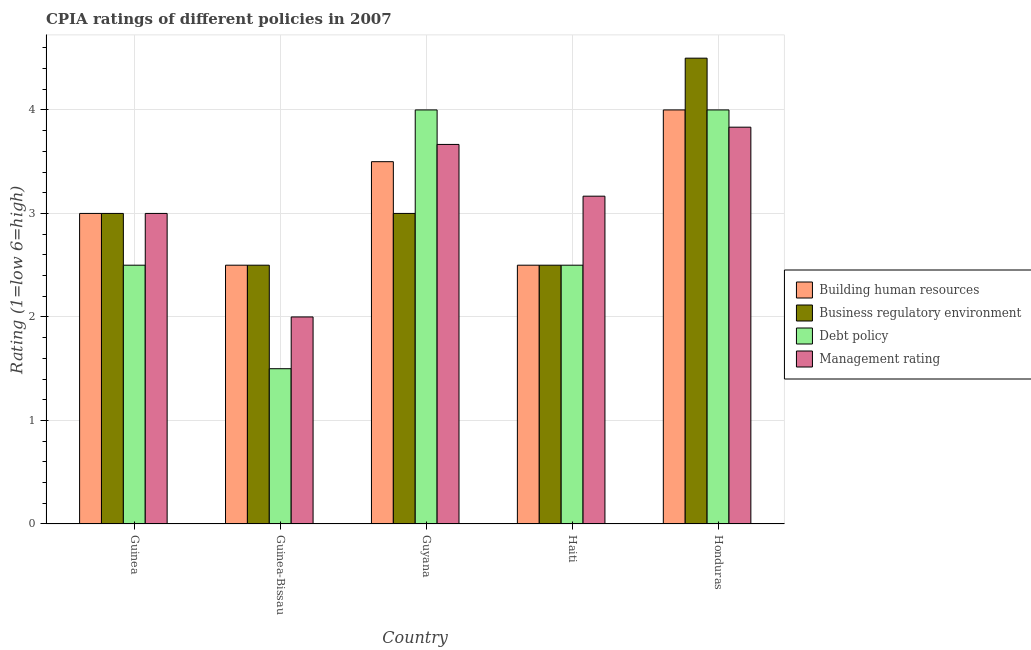How many groups of bars are there?
Make the answer very short. 5. Are the number of bars per tick equal to the number of legend labels?
Your answer should be compact. Yes. How many bars are there on the 1st tick from the left?
Give a very brief answer. 4. How many bars are there on the 3rd tick from the right?
Your response must be concise. 4. What is the label of the 4th group of bars from the left?
Make the answer very short. Haiti. In how many cases, is the number of bars for a given country not equal to the number of legend labels?
Keep it short and to the point. 0. Across all countries, what is the maximum cpia rating of management?
Make the answer very short. 3.83. Across all countries, what is the minimum cpia rating of debt policy?
Your answer should be compact. 1.5. In which country was the cpia rating of business regulatory environment maximum?
Give a very brief answer. Honduras. In which country was the cpia rating of building human resources minimum?
Keep it short and to the point. Guinea-Bissau. What is the total cpia rating of debt policy in the graph?
Make the answer very short. 14.5. What is the difference between the cpia rating of building human resources in Guinea-Bissau and that in Honduras?
Provide a succinct answer. -1.5. What is the average cpia rating of building human resources per country?
Provide a short and direct response. 3.1. What is the difference between the cpia rating of debt policy and cpia rating of management in Honduras?
Provide a short and direct response. 0.17. In how many countries, is the cpia rating of building human resources greater than 0.6000000000000001 ?
Give a very brief answer. 5. What is the ratio of the cpia rating of building human resources in Guyana to that in Honduras?
Offer a terse response. 0.88. Is the difference between the cpia rating of building human resources in Guinea and Haiti greater than the difference between the cpia rating of business regulatory environment in Guinea and Haiti?
Offer a very short reply. No. In how many countries, is the cpia rating of management greater than the average cpia rating of management taken over all countries?
Give a very brief answer. 3. Is the sum of the cpia rating of building human resources in Guyana and Honduras greater than the maximum cpia rating of debt policy across all countries?
Your response must be concise. Yes. What does the 2nd bar from the left in Guyana represents?
Ensure brevity in your answer.  Business regulatory environment. What does the 1st bar from the right in Guinea-Bissau represents?
Provide a succinct answer. Management rating. How many bars are there?
Your answer should be very brief. 20. Are all the bars in the graph horizontal?
Your response must be concise. No. How many countries are there in the graph?
Offer a very short reply. 5. What is the difference between two consecutive major ticks on the Y-axis?
Ensure brevity in your answer.  1. Does the graph contain any zero values?
Your answer should be compact. No. What is the title of the graph?
Keep it short and to the point. CPIA ratings of different policies in 2007. Does "Offering training" appear as one of the legend labels in the graph?
Your answer should be compact. No. What is the Rating (1=low 6=high) in Building human resources in Guinea?
Your answer should be very brief. 3. What is the Rating (1=low 6=high) in Business regulatory environment in Guinea-Bissau?
Keep it short and to the point. 2.5. What is the Rating (1=low 6=high) in Building human resources in Guyana?
Ensure brevity in your answer.  3.5. What is the Rating (1=low 6=high) of Management rating in Guyana?
Ensure brevity in your answer.  3.67. What is the Rating (1=low 6=high) in Building human resources in Haiti?
Your answer should be very brief. 2.5. What is the Rating (1=low 6=high) in Business regulatory environment in Haiti?
Keep it short and to the point. 2.5. What is the Rating (1=low 6=high) of Management rating in Haiti?
Your response must be concise. 3.17. What is the Rating (1=low 6=high) in Building human resources in Honduras?
Your answer should be compact. 4. What is the Rating (1=low 6=high) in Management rating in Honduras?
Give a very brief answer. 3.83. Across all countries, what is the maximum Rating (1=low 6=high) of Building human resources?
Offer a terse response. 4. Across all countries, what is the maximum Rating (1=low 6=high) of Business regulatory environment?
Keep it short and to the point. 4.5. Across all countries, what is the maximum Rating (1=low 6=high) of Management rating?
Provide a succinct answer. 3.83. What is the total Rating (1=low 6=high) in Building human resources in the graph?
Your answer should be very brief. 15.5. What is the total Rating (1=low 6=high) in Debt policy in the graph?
Offer a terse response. 14.5. What is the total Rating (1=low 6=high) of Management rating in the graph?
Ensure brevity in your answer.  15.67. What is the difference between the Rating (1=low 6=high) of Business regulatory environment in Guinea and that in Guinea-Bissau?
Offer a terse response. 0.5. What is the difference between the Rating (1=low 6=high) in Management rating in Guinea and that in Guinea-Bissau?
Your answer should be compact. 1. What is the difference between the Rating (1=low 6=high) in Building human resources in Guinea and that in Guyana?
Make the answer very short. -0.5. What is the difference between the Rating (1=low 6=high) of Business regulatory environment in Guinea and that in Guyana?
Give a very brief answer. 0. What is the difference between the Rating (1=low 6=high) of Debt policy in Guinea and that in Guyana?
Make the answer very short. -1.5. What is the difference between the Rating (1=low 6=high) in Management rating in Guinea and that in Guyana?
Give a very brief answer. -0.67. What is the difference between the Rating (1=low 6=high) of Building human resources in Guinea and that in Haiti?
Your answer should be very brief. 0.5. What is the difference between the Rating (1=low 6=high) in Debt policy in Guinea and that in Haiti?
Make the answer very short. 0. What is the difference between the Rating (1=low 6=high) of Business regulatory environment in Guinea and that in Honduras?
Your answer should be very brief. -1.5. What is the difference between the Rating (1=low 6=high) of Management rating in Guinea and that in Honduras?
Ensure brevity in your answer.  -0.83. What is the difference between the Rating (1=low 6=high) of Debt policy in Guinea-Bissau and that in Guyana?
Give a very brief answer. -2.5. What is the difference between the Rating (1=low 6=high) of Management rating in Guinea-Bissau and that in Guyana?
Your answer should be compact. -1.67. What is the difference between the Rating (1=low 6=high) of Building human resources in Guinea-Bissau and that in Haiti?
Ensure brevity in your answer.  0. What is the difference between the Rating (1=low 6=high) in Management rating in Guinea-Bissau and that in Haiti?
Offer a terse response. -1.17. What is the difference between the Rating (1=low 6=high) in Management rating in Guinea-Bissau and that in Honduras?
Your response must be concise. -1.83. What is the difference between the Rating (1=low 6=high) of Building human resources in Guyana and that in Haiti?
Your answer should be compact. 1. What is the difference between the Rating (1=low 6=high) in Debt policy in Guyana and that in Haiti?
Provide a succinct answer. 1.5. What is the difference between the Rating (1=low 6=high) in Debt policy in Guyana and that in Honduras?
Give a very brief answer. 0. What is the difference between the Rating (1=low 6=high) in Building human resources in Haiti and that in Honduras?
Your answer should be very brief. -1.5. What is the difference between the Rating (1=low 6=high) of Business regulatory environment in Haiti and that in Honduras?
Give a very brief answer. -2. What is the difference between the Rating (1=low 6=high) in Debt policy in Haiti and that in Honduras?
Make the answer very short. -1.5. What is the difference between the Rating (1=low 6=high) in Building human resources in Guinea and the Rating (1=low 6=high) in Business regulatory environment in Guinea-Bissau?
Ensure brevity in your answer.  0.5. What is the difference between the Rating (1=low 6=high) in Building human resources in Guinea and the Rating (1=low 6=high) in Management rating in Guyana?
Make the answer very short. -0.67. What is the difference between the Rating (1=low 6=high) of Business regulatory environment in Guinea and the Rating (1=low 6=high) of Debt policy in Guyana?
Give a very brief answer. -1. What is the difference between the Rating (1=low 6=high) in Business regulatory environment in Guinea and the Rating (1=low 6=high) in Management rating in Guyana?
Keep it short and to the point. -0.67. What is the difference between the Rating (1=low 6=high) in Debt policy in Guinea and the Rating (1=low 6=high) in Management rating in Guyana?
Ensure brevity in your answer.  -1.17. What is the difference between the Rating (1=low 6=high) of Building human resources in Guinea and the Rating (1=low 6=high) of Business regulatory environment in Haiti?
Your answer should be compact. 0.5. What is the difference between the Rating (1=low 6=high) in Building human resources in Guinea and the Rating (1=low 6=high) in Management rating in Haiti?
Provide a succinct answer. -0.17. What is the difference between the Rating (1=low 6=high) of Debt policy in Guinea and the Rating (1=low 6=high) of Management rating in Haiti?
Offer a very short reply. -0.67. What is the difference between the Rating (1=low 6=high) of Building human resources in Guinea and the Rating (1=low 6=high) of Management rating in Honduras?
Offer a terse response. -0.83. What is the difference between the Rating (1=low 6=high) of Business regulatory environment in Guinea and the Rating (1=low 6=high) of Debt policy in Honduras?
Your answer should be compact. -1. What is the difference between the Rating (1=low 6=high) in Debt policy in Guinea and the Rating (1=low 6=high) in Management rating in Honduras?
Ensure brevity in your answer.  -1.33. What is the difference between the Rating (1=low 6=high) of Building human resources in Guinea-Bissau and the Rating (1=low 6=high) of Business regulatory environment in Guyana?
Your answer should be very brief. -0.5. What is the difference between the Rating (1=low 6=high) of Building human resources in Guinea-Bissau and the Rating (1=low 6=high) of Debt policy in Guyana?
Offer a very short reply. -1.5. What is the difference between the Rating (1=low 6=high) of Building human resources in Guinea-Bissau and the Rating (1=low 6=high) of Management rating in Guyana?
Keep it short and to the point. -1.17. What is the difference between the Rating (1=low 6=high) in Business regulatory environment in Guinea-Bissau and the Rating (1=low 6=high) in Management rating in Guyana?
Offer a terse response. -1.17. What is the difference between the Rating (1=low 6=high) of Debt policy in Guinea-Bissau and the Rating (1=low 6=high) of Management rating in Guyana?
Give a very brief answer. -2.17. What is the difference between the Rating (1=low 6=high) in Building human resources in Guinea-Bissau and the Rating (1=low 6=high) in Business regulatory environment in Haiti?
Offer a terse response. 0. What is the difference between the Rating (1=low 6=high) of Building human resources in Guinea-Bissau and the Rating (1=low 6=high) of Debt policy in Haiti?
Provide a short and direct response. 0. What is the difference between the Rating (1=low 6=high) of Debt policy in Guinea-Bissau and the Rating (1=low 6=high) of Management rating in Haiti?
Provide a short and direct response. -1.67. What is the difference between the Rating (1=low 6=high) in Building human resources in Guinea-Bissau and the Rating (1=low 6=high) in Management rating in Honduras?
Keep it short and to the point. -1.33. What is the difference between the Rating (1=low 6=high) of Business regulatory environment in Guinea-Bissau and the Rating (1=low 6=high) of Debt policy in Honduras?
Give a very brief answer. -1.5. What is the difference between the Rating (1=low 6=high) of Business regulatory environment in Guinea-Bissau and the Rating (1=low 6=high) of Management rating in Honduras?
Offer a terse response. -1.33. What is the difference between the Rating (1=low 6=high) in Debt policy in Guinea-Bissau and the Rating (1=low 6=high) in Management rating in Honduras?
Make the answer very short. -2.33. What is the difference between the Rating (1=low 6=high) in Building human resources in Guyana and the Rating (1=low 6=high) in Business regulatory environment in Haiti?
Your answer should be compact. 1. What is the difference between the Rating (1=low 6=high) of Business regulatory environment in Guyana and the Rating (1=low 6=high) of Debt policy in Haiti?
Keep it short and to the point. 0.5. What is the difference between the Rating (1=low 6=high) in Debt policy in Guyana and the Rating (1=low 6=high) in Management rating in Honduras?
Make the answer very short. 0.17. What is the difference between the Rating (1=low 6=high) in Building human resources in Haiti and the Rating (1=low 6=high) in Business regulatory environment in Honduras?
Offer a very short reply. -2. What is the difference between the Rating (1=low 6=high) in Building human resources in Haiti and the Rating (1=low 6=high) in Management rating in Honduras?
Keep it short and to the point. -1.33. What is the difference between the Rating (1=low 6=high) in Business regulatory environment in Haiti and the Rating (1=low 6=high) in Debt policy in Honduras?
Ensure brevity in your answer.  -1.5. What is the difference between the Rating (1=low 6=high) of Business regulatory environment in Haiti and the Rating (1=low 6=high) of Management rating in Honduras?
Make the answer very short. -1.33. What is the difference between the Rating (1=low 6=high) of Debt policy in Haiti and the Rating (1=low 6=high) of Management rating in Honduras?
Offer a terse response. -1.33. What is the average Rating (1=low 6=high) in Building human resources per country?
Keep it short and to the point. 3.1. What is the average Rating (1=low 6=high) in Management rating per country?
Your answer should be very brief. 3.13. What is the difference between the Rating (1=low 6=high) of Building human resources and Rating (1=low 6=high) of Business regulatory environment in Guinea?
Provide a short and direct response. 0. What is the difference between the Rating (1=low 6=high) of Business regulatory environment and Rating (1=low 6=high) of Debt policy in Guinea?
Provide a short and direct response. 0.5. What is the difference between the Rating (1=low 6=high) in Business regulatory environment and Rating (1=low 6=high) in Management rating in Guinea-Bissau?
Your response must be concise. 0.5. What is the difference between the Rating (1=low 6=high) in Building human resources and Rating (1=low 6=high) in Debt policy in Guyana?
Ensure brevity in your answer.  -0.5. What is the difference between the Rating (1=low 6=high) in Debt policy and Rating (1=low 6=high) in Management rating in Guyana?
Give a very brief answer. 0.33. What is the difference between the Rating (1=low 6=high) in Business regulatory environment and Rating (1=low 6=high) in Debt policy in Haiti?
Provide a short and direct response. 0. What is the difference between the Rating (1=low 6=high) of Debt policy and Rating (1=low 6=high) of Management rating in Haiti?
Offer a terse response. -0.67. What is the difference between the Rating (1=low 6=high) in Building human resources and Rating (1=low 6=high) in Business regulatory environment in Honduras?
Ensure brevity in your answer.  -0.5. What is the difference between the Rating (1=low 6=high) of Building human resources and Rating (1=low 6=high) of Debt policy in Honduras?
Give a very brief answer. 0. What is the difference between the Rating (1=low 6=high) in Building human resources and Rating (1=low 6=high) in Management rating in Honduras?
Offer a terse response. 0.17. What is the difference between the Rating (1=low 6=high) of Business regulatory environment and Rating (1=low 6=high) of Management rating in Honduras?
Provide a short and direct response. 0.67. What is the difference between the Rating (1=low 6=high) of Debt policy and Rating (1=low 6=high) of Management rating in Honduras?
Your answer should be compact. 0.17. What is the ratio of the Rating (1=low 6=high) in Management rating in Guinea to that in Guinea-Bissau?
Your response must be concise. 1.5. What is the ratio of the Rating (1=low 6=high) of Building human resources in Guinea to that in Guyana?
Keep it short and to the point. 0.86. What is the ratio of the Rating (1=low 6=high) of Debt policy in Guinea to that in Guyana?
Give a very brief answer. 0.62. What is the ratio of the Rating (1=low 6=high) of Management rating in Guinea to that in Guyana?
Offer a very short reply. 0.82. What is the ratio of the Rating (1=low 6=high) of Business regulatory environment in Guinea to that in Haiti?
Ensure brevity in your answer.  1.2. What is the ratio of the Rating (1=low 6=high) of Management rating in Guinea to that in Haiti?
Make the answer very short. 0.95. What is the ratio of the Rating (1=low 6=high) in Building human resources in Guinea to that in Honduras?
Your answer should be compact. 0.75. What is the ratio of the Rating (1=low 6=high) in Debt policy in Guinea to that in Honduras?
Make the answer very short. 0.62. What is the ratio of the Rating (1=low 6=high) of Management rating in Guinea to that in Honduras?
Ensure brevity in your answer.  0.78. What is the ratio of the Rating (1=low 6=high) of Building human resources in Guinea-Bissau to that in Guyana?
Ensure brevity in your answer.  0.71. What is the ratio of the Rating (1=low 6=high) of Debt policy in Guinea-Bissau to that in Guyana?
Your answer should be compact. 0.38. What is the ratio of the Rating (1=low 6=high) of Management rating in Guinea-Bissau to that in Guyana?
Provide a succinct answer. 0.55. What is the ratio of the Rating (1=low 6=high) in Business regulatory environment in Guinea-Bissau to that in Haiti?
Offer a terse response. 1. What is the ratio of the Rating (1=low 6=high) in Management rating in Guinea-Bissau to that in Haiti?
Provide a succinct answer. 0.63. What is the ratio of the Rating (1=low 6=high) of Business regulatory environment in Guinea-Bissau to that in Honduras?
Your answer should be compact. 0.56. What is the ratio of the Rating (1=low 6=high) of Management rating in Guinea-Bissau to that in Honduras?
Offer a terse response. 0.52. What is the ratio of the Rating (1=low 6=high) in Building human resources in Guyana to that in Haiti?
Your answer should be compact. 1.4. What is the ratio of the Rating (1=low 6=high) of Business regulatory environment in Guyana to that in Haiti?
Offer a very short reply. 1.2. What is the ratio of the Rating (1=low 6=high) of Management rating in Guyana to that in Haiti?
Give a very brief answer. 1.16. What is the ratio of the Rating (1=low 6=high) in Building human resources in Guyana to that in Honduras?
Make the answer very short. 0.88. What is the ratio of the Rating (1=low 6=high) in Business regulatory environment in Guyana to that in Honduras?
Make the answer very short. 0.67. What is the ratio of the Rating (1=low 6=high) of Management rating in Guyana to that in Honduras?
Give a very brief answer. 0.96. What is the ratio of the Rating (1=low 6=high) of Building human resources in Haiti to that in Honduras?
Give a very brief answer. 0.62. What is the ratio of the Rating (1=low 6=high) of Business regulatory environment in Haiti to that in Honduras?
Make the answer very short. 0.56. What is the ratio of the Rating (1=low 6=high) in Management rating in Haiti to that in Honduras?
Give a very brief answer. 0.83. What is the difference between the highest and the second highest Rating (1=low 6=high) in Building human resources?
Keep it short and to the point. 0.5. What is the difference between the highest and the second highest Rating (1=low 6=high) of Debt policy?
Your answer should be compact. 0. What is the difference between the highest and the lowest Rating (1=low 6=high) in Building human resources?
Your response must be concise. 1.5. What is the difference between the highest and the lowest Rating (1=low 6=high) in Business regulatory environment?
Your answer should be compact. 2. What is the difference between the highest and the lowest Rating (1=low 6=high) of Debt policy?
Provide a short and direct response. 2.5. What is the difference between the highest and the lowest Rating (1=low 6=high) of Management rating?
Your answer should be compact. 1.83. 